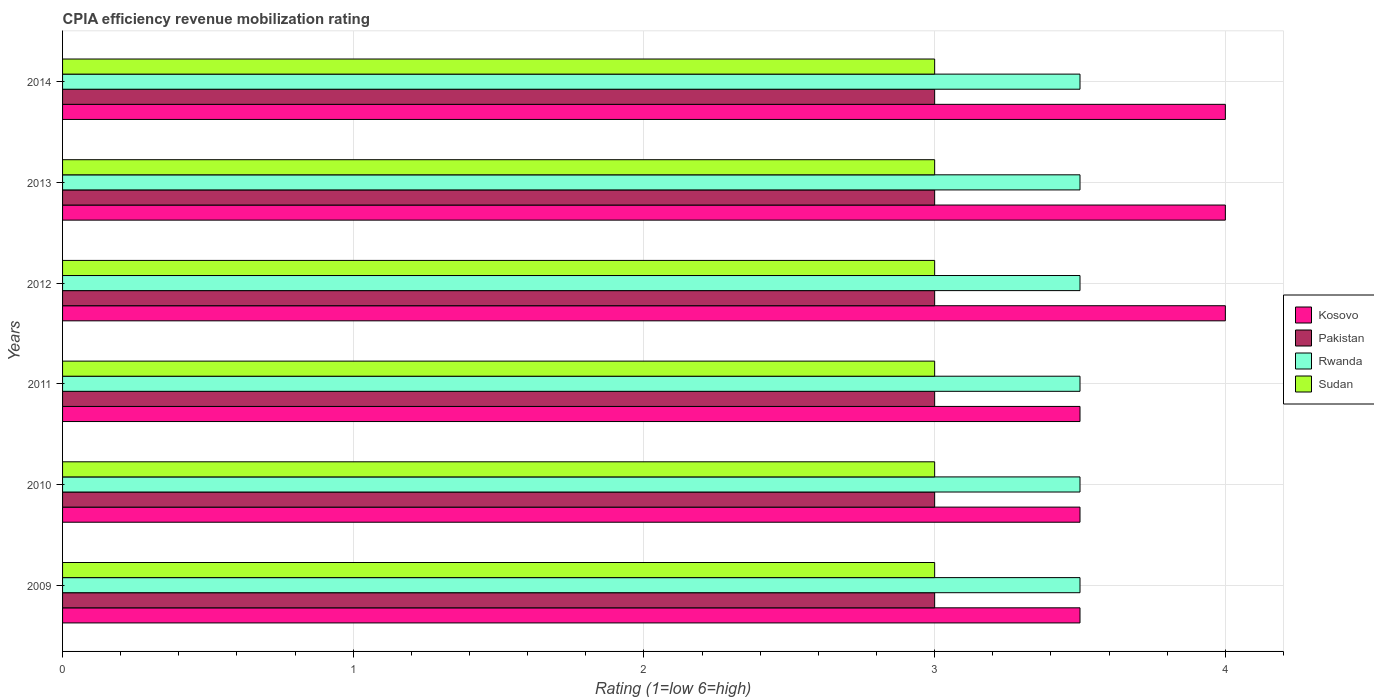How many bars are there on the 3rd tick from the top?
Your response must be concise. 4. How many bars are there on the 3rd tick from the bottom?
Your answer should be very brief. 4. Across all years, what is the minimum CPIA rating in Sudan?
Offer a terse response. 3. In which year was the CPIA rating in Sudan maximum?
Make the answer very short. 2009. In which year was the CPIA rating in Sudan minimum?
Provide a succinct answer. 2009. What is the total CPIA rating in Rwanda in the graph?
Offer a very short reply. 21. What is the difference between the CPIA rating in Kosovo in 2014 and the CPIA rating in Rwanda in 2013?
Provide a succinct answer. 0.5. What is the ratio of the CPIA rating in Rwanda in 2009 to that in 2014?
Provide a short and direct response. 1. Is the difference between the CPIA rating in Kosovo in 2011 and 2013 greater than the difference between the CPIA rating in Rwanda in 2011 and 2013?
Make the answer very short. No. What is the difference between the highest and the second highest CPIA rating in Rwanda?
Your answer should be very brief. 0. What is the difference between the highest and the lowest CPIA rating in Kosovo?
Your answer should be compact. 0.5. Is it the case that in every year, the sum of the CPIA rating in Rwanda and CPIA rating in Sudan is greater than the sum of CPIA rating in Pakistan and CPIA rating in Kosovo?
Offer a terse response. No. What does the 1st bar from the bottom in 2013 represents?
Make the answer very short. Kosovo. Is it the case that in every year, the sum of the CPIA rating in Kosovo and CPIA rating in Rwanda is greater than the CPIA rating in Pakistan?
Your answer should be compact. Yes. How many bars are there?
Your answer should be very brief. 24. Are all the bars in the graph horizontal?
Keep it short and to the point. Yes. How many years are there in the graph?
Offer a terse response. 6. What is the difference between two consecutive major ticks on the X-axis?
Give a very brief answer. 1. Does the graph contain grids?
Provide a short and direct response. Yes. Where does the legend appear in the graph?
Provide a short and direct response. Center right. How many legend labels are there?
Offer a very short reply. 4. What is the title of the graph?
Your response must be concise. CPIA efficiency revenue mobilization rating. What is the label or title of the X-axis?
Provide a succinct answer. Rating (1=low 6=high). What is the Rating (1=low 6=high) of Rwanda in 2009?
Offer a terse response. 3.5. What is the Rating (1=low 6=high) in Sudan in 2009?
Provide a short and direct response. 3. What is the Rating (1=low 6=high) of Rwanda in 2010?
Provide a short and direct response. 3.5. What is the Rating (1=low 6=high) of Pakistan in 2011?
Give a very brief answer. 3. What is the Rating (1=low 6=high) in Rwanda in 2011?
Make the answer very short. 3.5. What is the Rating (1=low 6=high) of Kosovo in 2012?
Your response must be concise. 4. What is the Rating (1=low 6=high) in Sudan in 2012?
Your response must be concise. 3. What is the Rating (1=low 6=high) in Kosovo in 2013?
Provide a short and direct response. 4. What is the Rating (1=low 6=high) in Pakistan in 2013?
Keep it short and to the point. 3. What is the Rating (1=low 6=high) in Rwanda in 2013?
Offer a very short reply. 3.5. What is the Rating (1=low 6=high) of Sudan in 2013?
Offer a terse response. 3. What is the Rating (1=low 6=high) of Kosovo in 2014?
Your answer should be compact. 4. What is the Rating (1=low 6=high) in Pakistan in 2014?
Your response must be concise. 3. What is the Rating (1=low 6=high) of Rwanda in 2014?
Your response must be concise. 3.5. Across all years, what is the maximum Rating (1=low 6=high) of Kosovo?
Your response must be concise. 4. Across all years, what is the maximum Rating (1=low 6=high) in Pakistan?
Offer a terse response. 3. Across all years, what is the maximum Rating (1=low 6=high) of Rwanda?
Give a very brief answer. 3.5. Across all years, what is the maximum Rating (1=low 6=high) of Sudan?
Your answer should be very brief. 3. Across all years, what is the minimum Rating (1=low 6=high) in Kosovo?
Give a very brief answer. 3.5. Across all years, what is the minimum Rating (1=low 6=high) in Sudan?
Provide a short and direct response. 3. What is the total Rating (1=low 6=high) in Pakistan in the graph?
Give a very brief answer. 18. What is the total Rating (1=low 6=high) in Rwanda in the graph?
Offer a terse response. 21. What is the total Rating (1=low 6=high) in Sudan in the graph?
Offer a very short reply. 18. What is the difference between the Rating (1=low 6=high) in Kosovo in 2009 and that in 2010?
Make the answer very short. 0. What is the difference between the Rating (1=low 6=high) of Pakistan in 2009 and that in 2010?
Offer a very short reply. 0. What is the difference between the Rating (1=low 6=high) in Sudan in 2009 and that in 2010?
Ensure brevity in your answer.  0. What is the difference between the Rating (1=low 6=high) in Pakistan in 2009 and that in 2011?
Your answer should be very brief. 0. What is the difference between the Rating (1=low 6=high) in Rwanda in 2009 and that in 2011?
Your answer should be compact. 0. What is the difference between the Rating (1=low 6=high) of Pakistan in 2009 and that in 2013?
Make the answer very short. 0. What is the difference between the Rating (1=low 6=high) of Sudan in 2009 and that in 2013?
Offer a terse response. 0. What is the difference between the Rating (1=low 6=high) in Pakistan in 2009 and that in 2014?
Keep it short and to the point. 0. What is the difference between the Rating (1=low 6=high) of Rwanda in 2009 and that in 2014?
Provide a succinct answer. 0. What is the difference between the Rating (1=low 6=high) in Kosovo in 2010 and that in 2011?
Offer a very short reply. 0. What is the difference between the Rating (1=low 6=high) in Pakistan in 2010 and that in 2011?
Provide a succinct answer. 0. What is the difference between the Rating (1=low 6=high) of Rwanda in 2010 and that in 2011?
Provide a short and direct response. 0. What is the difference between the Rating (1=low 6=high) in Kosovo in 2010 and that in 2012?
Your answer should be very brief. -0.5. What is the difference between the Rating (1=low 6=high) in Pakistan in 2010 and that in 2012?
Provide a succinct answer. 0. What is the difference between the Rating (1=low 6=high) of Rwanda in 2010 and that in 2012?
Offer a very short reply. 0. What is the difference between the Rating (1=low 6=high) of Sudan in 2010 and that in 2012?
Keep it short and to the point. 0. What is the difference between the Rating (1=low 6=high) in Kosovo in 2010 and that in 2013?
Your answer should be very brief. -0.5. What is the difference between the Rating (1=low 6=high) of Rwanda in 2010 and that in 2013?
Offer a terse response. 0. What is the difference between the Rating (1=low 6=high) in Sudan in 2010 and that in 2013?
Your answer should be very brief. 0. What is the difference between the Rating (1=low 6=high) of Kosovo in 2010 and that in 2014?
Ensure brevity in your answer.  -0.5. What is the difference between the Rating (1=low 6=high) of Kosovo in 2011 and that in 2012?
Provide a succinct answer. -0.5. What is the difference between the Rating (1=low 6=high) of Pakistan in 2011 and that in 2012?
Keep it short and to the point. 0. What is the difference between the Rating (1=low 6=high) in Rwanda in 2011 and that in 2012?
Keep it short and to the point. 0. What is the difference between the Rating (1=low 6=high) in Kosovo in 2011 and that in 2013?
Your answer should be very brief. -0.5. What is the difference between the Rating (1=low 6=high) in Pakistan in 2011 and that in 2013?
Make the answer very short. 0. What is the difference between the Rating (1=low 6=high) of Kosovo in 2011 and that in 2014?
Your answer should be compact. -0.5. What is the difference between the Rating (1=low 6=high) in Pakistan in 2011 and that in 2014?
Keep it short and to the point. 0. What is the difference between the Rating (1=low 6=high) of Sudan in 2011 and that in 2014?
Your answer should be compact. 0. What is the difference between the Rating (1=low 6=high) of Kosovo in 2012 and that in 2013?
Ensure brevity in your answer.  0. What is the difference between the Rating (1=low 6=high) in Rwanda in 2012 and that in 2013?
Your response must be concise. 0. What is the difference between the Rating (1=low 6=high) in Sudan in 2012 and that in 2014?
Provide a succinct answer. 0. What is the difference between the Rating (1=low 6=high) of Pakistan in 2013 and that in 2014?
Offer a very short reply. 0. What is the difference between the Rating (1=low 6=high) in Kosovo in 2009 and the Rating (1=low 6=high) in Pakistan in 2010?
Give a very brief answer. 0.5. What is the difference between the Rating (1=low 6=high) in Rwanda in 2009 and the Rating (1=low 6=high) in Sudan in 2010?
Give a very brief answer. 0.5. What is the difference between the Rating (1=low 6=high) in Pakistan in 2009 and the Rating (1=low 6=high) in Sudan in 2011?
Your answer should be very brief. 0. What is the difference between the Rating (1=low 6=high) in Rwanda in 2009 and the Rating (1=low 6=high) in Sudan in 2011?
Your response must be concise. 0.5. What is the difference between the Rating (1=low 6=high) in Kosovo in 2009 and the Rating (1=low 6=high) in Rwanda in 2012?
Your response must be concise. 0. What is the difference between the Rating (1=low 6=high) in Kosovo in 2009 and the Rating (1=low 6=high) in Pakistan in 2013?
Your response must be concise. 0.5. What is the difference between the Rating (1=low 6=high) of Kosovo in 2009 and the Rating (1=low 6=high) of Rwanda in 2013?
Your answer should be very brief. 0. What is the difference between the Rating (1=low 6=high) of Kosovo in 2009 and the Rating (1=low 6=high) of Sudan in 2013?
Keep it short and to the point. 0.5. What is the difference between the Rating (1=low 6=high) of Kosovo in 2009 and the Rating (1=low 6=high) of Pakistan in 2014?
Keep it short and to the point. 0.5. What is the difference between the Rating (1=low 6=high) of Kosovo in 2009 and the Rating (1=low 6=high) of Sudan in 2014?
Your answer should be very brief. 0.5. What is the difference between the Rating (1=low 6=high) of Pakistan in 2009 and the Rating (1=low 6=high) of Rwanda in 2014?
Offer a very short reply. -0.5. What is the difference between the Rating (1=low 6=high) of Pakistan in 2009 and the Rating (1=low 6=high) of Sudan in 2014?
Provide a short and direct response. 0. What is the difference between the Rating (1=low 6=high) in Kosovo in 2010 and the Rating (1=low 6=high) in Pakistan in 2011?
Offer a very short reply. 0.5. What is the difference between the Rating (1=low 6=high) in Kosovo in 2010 and the Rating (1=low 6=high) in Rwanda in 2011?
Offer a terse response. 0. What is the difference between the Rating (1=low 6=high) of Pakistan in 2010 and the Rating (1=low 6=high) of Rwanda in 2011?
Ensure brevity in your answer.  -0.5. What is the difference between the Rating (1=low 6=high) in Kosovo in 2010 and the Rating (1=low 6=high) in Rwanda in 2012?
Offer a very short reply. 0. What is the difference between the Rating (1=low 6=high) of Kosovo in 2010 and the Rating (1=low 6=high) of Rwanda in 2013?
Keep it short and to the point. 0. What is the difference between the Rating (1=low 6=high) in Kosovo in 2010 and the Rating (1=low 6=high) in Sudan in 2013?
Your answer should be compact. 0.5. What is the difference between the Rating (1=low 6=high) in Kosovo in 2010 and the Rating (1=low 6=high) in Pakistan in 2014?
Your response must be concise. 0.5. What is the difference between the Rating (1=low 6=high) of Kosovo in 2010 and the Rating (1=low 6=high) of Rwanda in 2014?
Provide a short and direct response. 0. What is the difference between the Rating (1=low 6=high) of Kosovo in 2010 and the Rating (1=low 6=high) of Sudan in 2014?
Offer a terse response. 0.5. What is the difference between the Rating (1=low 6=high) in Pakistan in 2010 and the Rating (1=low 6=high) in Sudan in 2014?
Make the answer very short. 0. What is the difference between the Rating (1=low 6=high) in Kosovo in 2011 and the Rating (1=low 6=high) in Pakistan in 2013?
Provide a succinct answer. 0.5. What is the difference between the Rating (1=low 6=high) in Pakistan in 2011 and the Rating (1=low 6=high) in Rwanda in 2013?
Offer a very short reply. -0.5. What is the difference between the Rating (1=low 6=high) in Rwanda in 2011 and the Rating (1=low 6=high) in Sudan in 2013?
Ensure brevity in your answer.  0.5. What is the difference between the Rating (1=low 6=high) of Pakistan in 2011 and the Rating (1=low 6=high) of Rwanda in 2014?
Provide a short and direct response. -0.5. What is the difference between the Rating (1=low 6=high) of Pakistan in 2011 and the Rating (1=low 6=high) of Sudan in 2014?
Provide a short and direct response. 0. What is the difference between the Rating (1=low 6=high) of Kosovo in 2012 and the Rating (1=low 6=high) of Pakistan in 2013?
Provide a short and direct response. 1. What is the difference between the Rating (1=low 6=high) in Kosovo in 2012 and the Rating (1=low 6=high) in Rwanda in 2013?
Make the answer very short. 0.5. What is the difference between the Rating (1=low 6=high) in Kosovo in 2012 and the Rating (1=low 6=high) in Sudan in 2013?
Provide a succinct answer. 1. What is the difference between the Rating (1=low 6=high) of Pakistan in 2012 and the Rating (1=low 6=high) of Rwanda in 2013?
Your answer should be very brief. -0.5. What is the difference between the Rating (1=low 6=high) in Pakistan in 2012 and the Rating (1=low 6=high) in Sudan in 2013?
Offer a terse response. 0. What is the difference between the Rating (1=low 6=high) of Pakistan in 2012 and the Rating (1=low 6=high) of Rwanda in 2014?
Offer a very short reply. -0.5. What is the difference between the Rating (1=low 6=high) in Kosovo in 2013 and the Rating (1=low 6=high) in Pakistan in 2014?
Your answer should be compact. 1. What is the difference between the Rating (1=low 6=high) of Kosovo in 2013 and the Rating (1=low 6=high) of Sudan in 2014?
Your answer should be very brief. 1. What is the difference between the Rating (1=low 6=high) of Rwanda in 2013 and the Rating (1=low 6=high) of Sudan in 2014?
Give a very brief answer. 0.5. What is the average Rating (1=low 6=high) of Kosovo per year?
Offer a very short reply. 3.75. What is the average Rating (1=low 6=high) in Pakistan per year?
Ensure brevity in your answer.  3. What is the average Rating (1=low 6=high) in Sudan per year?
Your answer should be compact. 3. In the year 2009, what is the difference between the Rating (1=low 6=high) in Kosovo and Rating (1=low 6=high) in Pakistan?
Keep it short and to the point. 0.5. In the year 2009, what is the difference between the Rating (1=low 6=high) of Kosovo and Rating (1=low 6=high) of Rwanda?
Provide a succinct answer. 0. In the year 2009, what is the difference between the Rating (1=low 6=high) of Kosovo and Rating (1=low 6=high) of Sudan?
Provide a short and direct response. 0.5. In the year 2009, what is the difference between the Rating (1=low 6=high) in Pakistan and Rating (1=low 6=high) in Sudan?
Keep it short and to the point. 0. In the year 2010, what is the difference between the Rating (1=low 6=high) of Kosovo and Rating (1=low 6=high) of Sudan?
Offer a very short reply. 0.5. In the year 2010, what is the difference between the Rating (1=low 6=high) of Pakistan and Rating (1=low 6=high) of Sudan?
Your answer should be compact. 0. In the year 2010, what is the difference between the Rating (1=low 6=high) in Rwanda and Rating (1=low 6=high) in Sudan?
Offer a very short reply. 0.5. In the year 2011, what is the difference between the Rating (1=low 6=high) in Kosovo and Rating (1=low 6=high) in Pakistan?
Your answer should be compact. 0.5. In the year 2011, what is the difference between the Rating (1=low 6=high) of Kosovo and Rating (1=low 6=high) of Rwanda?
Your answer should be compact. 0. In the year 2011, what is the difference between the Rating (1=low 6=high) in Pakistan and Rating (1=low 6=high) in Sudan?
Provide a succinct answer. 0. In the year 2012, what is the difference between the Rating (1=low 6=high) of Kosovo and Rating (1=low 6=high) of Pakistan?
Your answer should be very brief. 1. In the year 2012, what is the difference between the Rating (1=low 6=high) in Kosovo and Rating (1=low 6=high) in Rwanda?
Provide a short and direct response. 0.5. In the year 2012, what is the difference between the Rating (1=low 6=high) of Kosovo and Rating (1=low 6=high) of Sudan?
Provide a short and direct response. 1. In the year 2013, what is the difference between the Rating (1=low 6=high) in Kosovo and Rating (1=low 6=high) in Pakistan?
Provide a succinct answer. 1. In the year 2013, what is the difference between the Rating (1=low 6=high) of Pakistan and Rating (1=low 6=high) of Rwanda?
Offer a very short reply. -0.5. In the year 2013, what is the difference between the Rating (1=low 6=high) of Pakistan and Rating (1=low 6=high) of Sudan?
Make the answer very short. 0. In the year 2014, what is the difference between the Rating (1=low 6=high) in Kosovo and Rating (1=low 6=high) in Pakistan?
Make the answer very short. 1. In the year 2014, what is the difference between the Rating (1=low 6=high) in Kosovo and Rating (1=low 6=high) in Rwanda?
Keep it short and to the point. 0.5. What is the ratio of the Rating (1=low 6=high) of Kosovo in 2009 to that in 2010?
Ensure brevity in your answer.  1. What is the ratio of the Rating (1=low 6=high) in Pakistan in 2009 to that in 2010?
Your answer should be compact. 1. What is the ratio of the Rating (1=low 6=high) in Pakistan in 2009 to that in 2011?
Your response must be concise. 1. What is the ratio of the Rating (1=low 6=high) in Rwanda in 2009 to that in 2011?
Keep it short and to the point. 1. What is the ratio of the Rating (1=low 6=high) of Kosovo in 2009 to that in 2012?
Give a very brief answer. 0.88. What is the ratio of the Rating (1=low 6=high) in Pakistan in 2009 to that in 2012?
Make the answer very short. 1. What is the ratio of the Rating (1=low 6=high) of Rwanda in 2009 to that in 2012?
Keep it short and to the point. 1. What is the ratio of the Rating (1=low 6=high) in Pakistan in 2009 to that in 2013?
Give a very brief answer. 1. What is the ratio of the Rating (1=low 6=high) in Rwanda in 2009 to that in 2013?
Your answer should be very brief. 1. What is the ratio of the Rating (1=low 6=high) in Rwanda in 2009 to that in 2014?
Your answer should be compact. 1. What is the ratio of the Rating (1=low 6=high) in Sudan in 2009 to that in 2014?
Your answer should be compact. 1. What is the ratio of the Rating (1=low 6=high) in Pakistan in 2010 to that in 2011?
Make the answer very short. 1. What is the ratio of the Rating (1=low 6=high) of Sudan in 2010 to that in 2011?
Provide a succinct answer. 1. What is the ratio of the Rating (1=low 6=high) in Kosovo in 2010 to that in 2012?
Provide a short and direct response. 0.88. What is the ratio of the Rating (1=low 6=high) of Rwanda in 2010 to that in 2012?
Offer a very short reply. 1. What is the ratio of the Rating (1=low 6=high) of Rwanda in 2010 to that in 2014?
Offer a terse response. 1. What is the ratio of the Rating (1=low 6=high) of Sudan in 2010 to that in 2014?
Ensure brevity in your answer.  1. What is the ratio of the Rating (1=low 6=high) in Kosovo in 2011 to that in 2012?
Give a very brief answer. 0.88. What is the ratio of the Rating (1=low 6=high) of Pakistan in 2011 to that in 2012?
Make the answer very short. 1. What is the ratio of the Rating (1=low 6=high) in Rwanda in 2011 to that in 2012?
Your answer should be very brief. 1. What is the ratio of the Rating (1=low 6=high) of Sudan in 2011 to that in 2012?
Your response must be concise. 1. What is the ratio of the Rating (1=low 6=high) of Rwanda in 2011 to that in 2013?
Your answer should be compact. 1. What is the ratio of the Rating (1=low 6=high) in Kosovo in 2011 to that in 2014?
Provide a succinct answer. 0.88. What is the ratio of the Rating (1=low 6=high) of Sudan in 2011 to that in 2014?
Make the answer very short. 1. What is the ratio of the Rating (1=low 6=high) in Pakistan in 2012 to that in 2013?
Your answer should be compact. 1. What is the ratio of the Rating (1=low 6=high) of Rwanda in 2012 to that in 2013?
Your answer should be very brief. 1. What is the ratio of the Rating (1=low 6=high) of Sudan in 2012 to that in 2013?
Offer a very short reply. 1. What is the ratio of the Rating (1=low 6=high) of Kosovo in 2012 to that in 2014?
Give a very brief answer. 1. What is the ratio of the Rating (1=low 6=high) of Pakistan in 2013 to that in 2014?
Ensure brevity in your answer.  1. What is the ratio of the Rating (1=low 6=high) in Rwanda in 2013 to that in 2014?
Your answer should be very brief. 1. What is the ratio of the Rating (1=low 6=high) of Sudan in 2013 to that in 2014?
Ensure brevity in your answer.  1. What is the difference between the highest and the second highest Rating (1=low 6=high) of Pakistan?
Provide a succinct answer. 0. What is the difference between the highest and the second highest Rating (1=low 6=high) of Rwanda?
Ensure brevity in your answer.  0. What is the difference between the highest and the lowest Rating (1=low 6=high) of Kosovo?
Your answer should be very brief. 0.5. What is the difference between the highest and the lowest Rating (1=low 6=high) of Pakistan?
Make the answer very short. 0. 